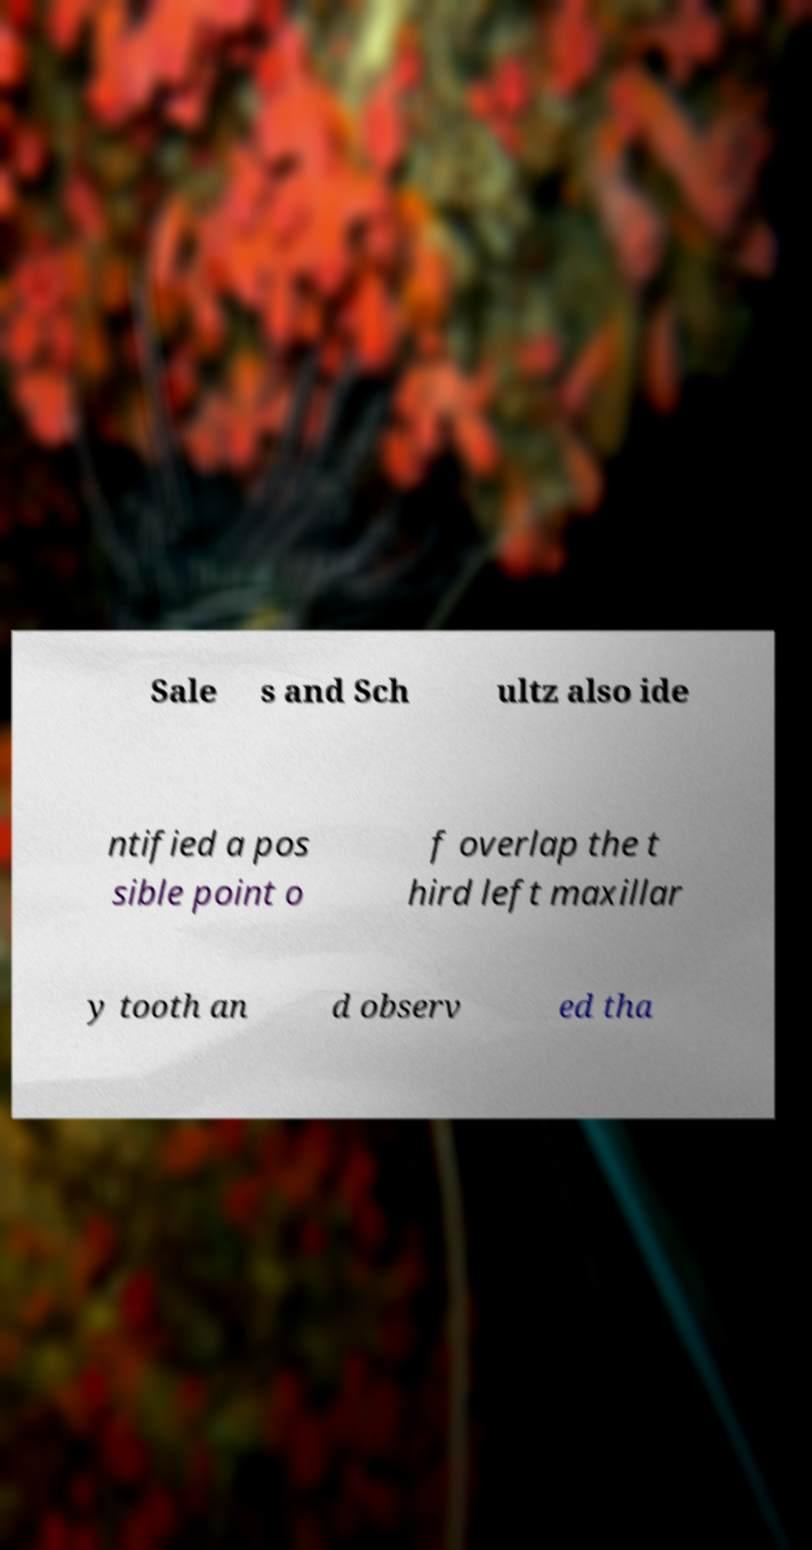For documentation purposes, I need the text within this image transcribed. Could you provide that? Sale s and Sch ultz also ide ntified a pos sible point o f overlap the t hird left maxillar y tooth an d observ ed tha 